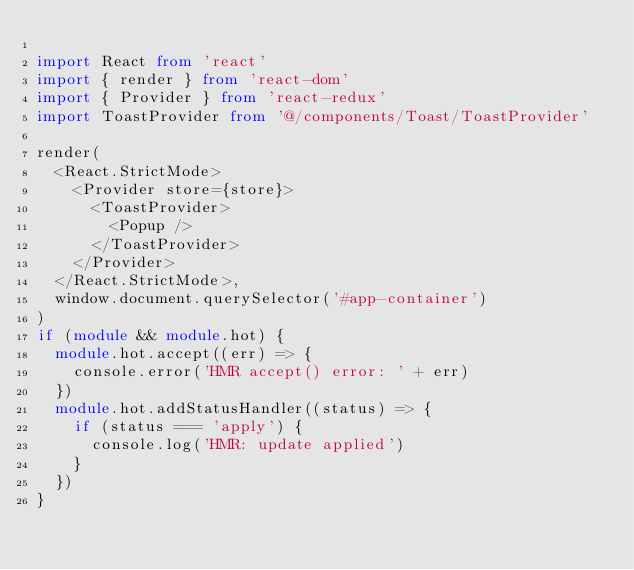Convert code to text. <code><loc_0><loc_0><loc_500><loc_500><_TypeScript_>
import React from 'react'
import { render } from 'react-dom'
import { Provider } from 'react-redux'
import ToastProvider from '@/components/Toast/ToastProvider'

render(
  <React.StrictMode>
    <Provider store={store}>
      <ToastProvider>
        <Popup />
      </ToastProvider>
    </Provider>
  </React.StrictMode>,
  window.document.querySelector('#app-container')
)
if (module && module.hot) {
  module.hot.accept((err) => {
    console.error('HMR accept() error: ' + err)
  })
  module.hot.addStatusHandler((status) => {
    if (status === 'apply') {
      console.log('HMR: update applied')
    }
  })
}
</code> 